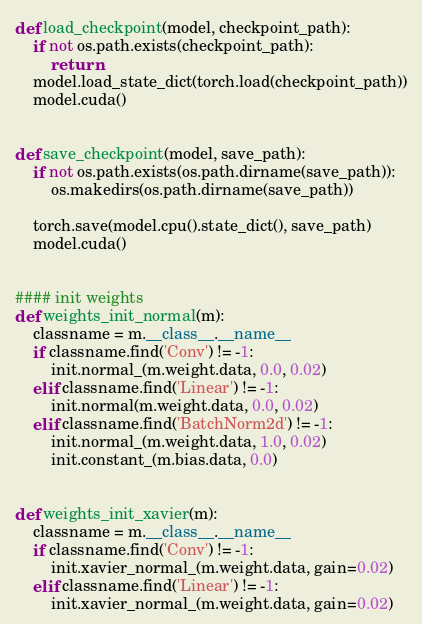Convert code to text. <code><loc_0><loc_0><loc_500><loc_500><_Python_>def load_checkpoint(model, checkpoint_path):
    if not os.path.exists(checkpoint_path):
        return
    model.load_state_dict(torch.load(checkpoint_path))
    model.cuda()

    
def save_checkpoint(model, save_path):
    if not os.path.exists(os.path.dirname(save_path)):
        os.makedirs(os.path.dirname(save_path))

    torch.save(model.cpu().state_dict(), save_path)
    model.cuda()


#### init weights
def weights_init_normal(m):
    classname = m.__class__.__name__
    if classname.find('Conv') != -1:
        init.normal_(m.weight.data, 0.0, 0.02)
    elif classname.find('Linear') != -1:
        init.normal(m.weight.data, 0.0, 0.02)
    elif classname.find('BatchNorm2d') != -1:
        init.normal_(m.weight.data, 1.0, 0.02)
        init.constant_(m.bias.data, 0.0)


def weights_init_xavier(m):
    classname = m.__class__.__name__
    if classname.find('Conv') != -1:
        init.xavier_normal_(m.weight.data, gain=0.02)
    elif classname.find('Linear') != -1:
        init.xavier_normal_(m.weight.data, gain=0.02)</code> 